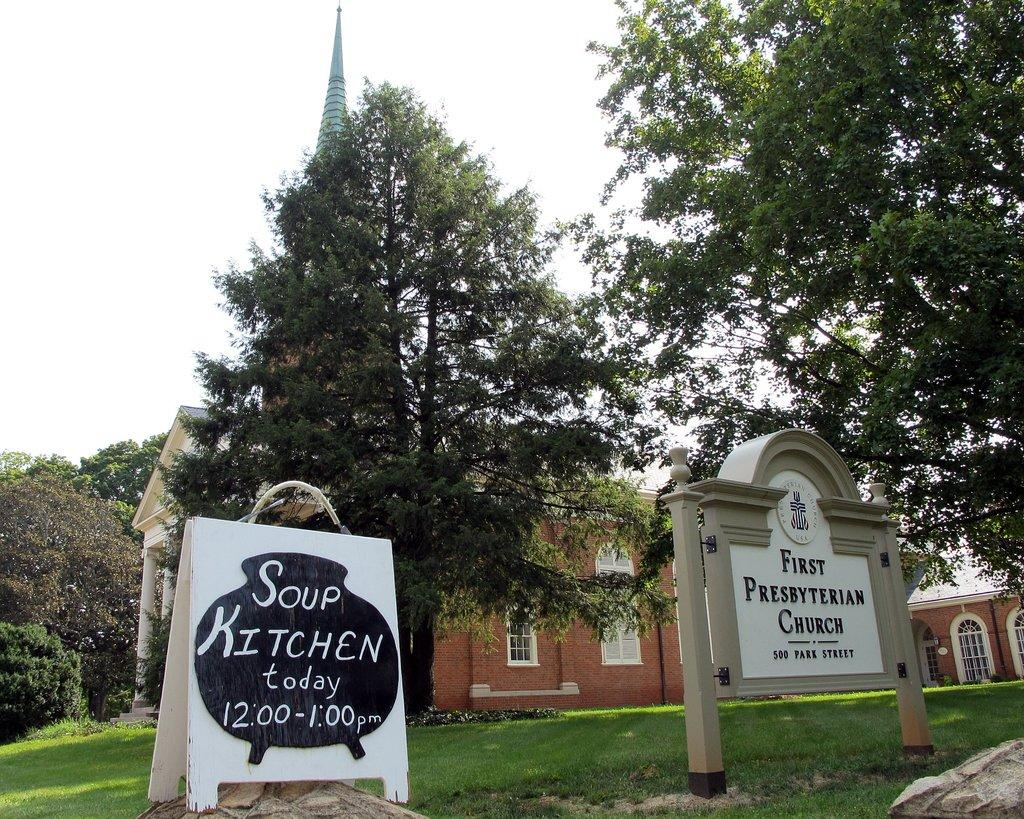What type of natural environment is visible in the image? There is grass and trees visible in the image. What other objects can be seen in the image? There are rocks, name boards, and a building with windows in the image. What is visible in the background of the image? The sky is visible in the background of the image. What type of feast is being prepared in the image? There is no indication of a feast being prepared in the image. Can you see any structures related to sailing in the image? There are no structures related to sailing visible in the image. 